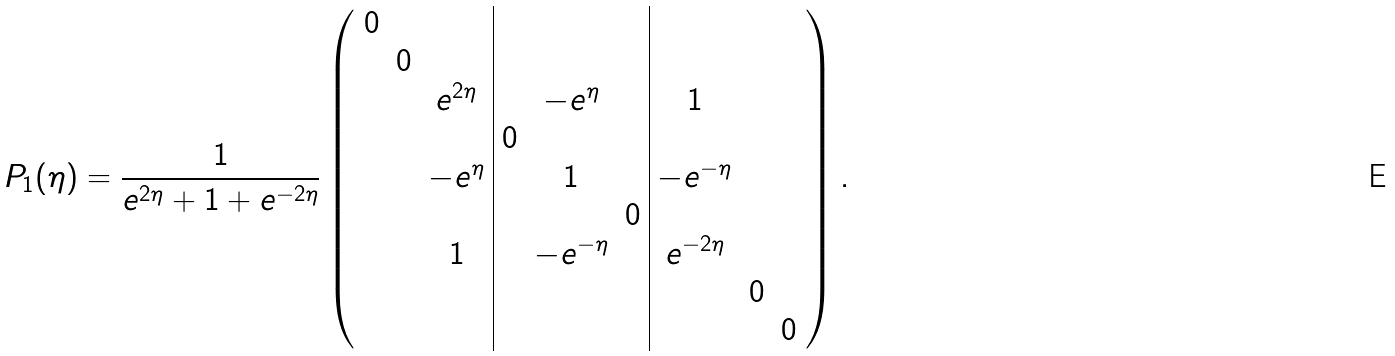<formula> <loc_0><loc_0><loc_500><loc_500>\, P _ { 1 } ( \eta ) = \frac { 1 } { e ^ { 2 \eta } + 1 + e ^ { - 2 \eta } } \left ( \begin{array} { c c c | c c c | c c c } 0 & & & & & & & & \\ & 0 & & & & & & & \\ & & e ^ { 2 \eta } & & - e ^ { \eta } & & 1 & & \\ & & & 0 & & & & & \\ & & - e ^ { \eta } & & 1 & & - e ^ { - \eta } & & \\ & & & & & 0 & & & \\ & & 1 & & - e ^ { - \eta } & & e ^ { - 2 \eta } & & \\ & & & & & & & 0 & \\ & & & & & & & & 0 \end{array} \right ) .</formula> 